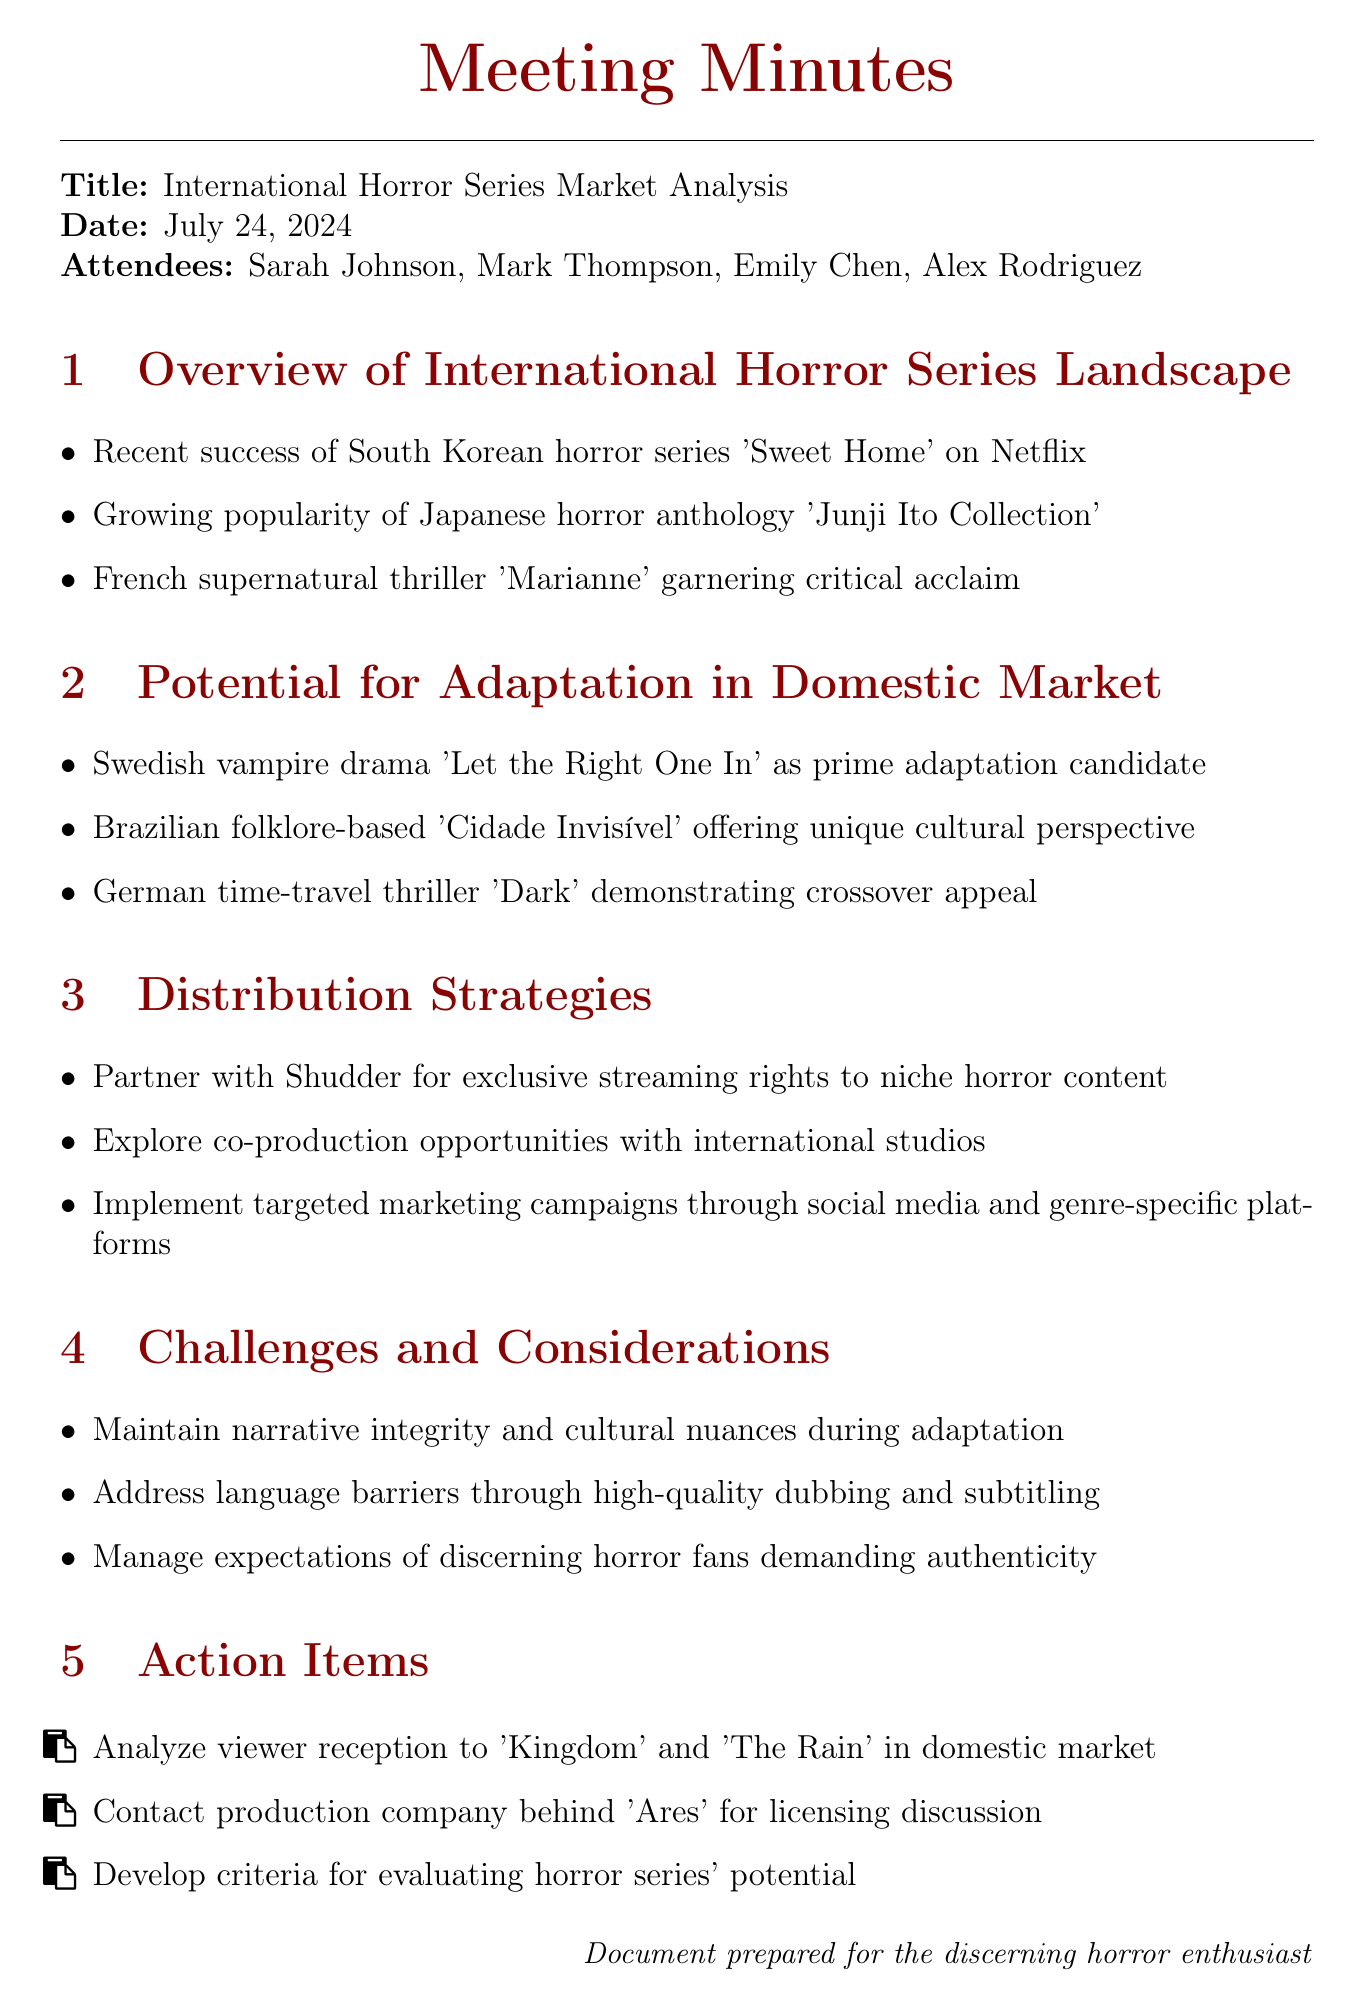What is the title of the meeting? The title of the meeting is provided at the beginning of the document.
Answer: International Horror Series Market Analysis Who is the market research analyst in the meeting? The attendees' list includes their respective roles, identifying the market research analyst.
Answer: Emily Chen Which South Korean horror series was mentioned as a recent success? The overview section lists key points, one of which includes the title of the successful series.
Answer: Sweet Home What international series is noted for its crossover appeal despite a complex narrative? The potential for adaptation section includes a specific German series that fits this description.
Answer: Dark What are the action items focused on? The action items section lists specific tasks to be undertaken, which can be summarized based on their context.
Answer: Analyzing viewer reception What is a challenge mentioned regarding adaptations? The challenges and considerations section highlights specific hurdles faced during adaptations, one of which involves narrative integrity.
Answer: Narrative integrity How many attendees were listed in the meeting? The document specifies the number of attendees in the introductory section.
Answer: Four Which streaming platform was mentioned for partnering? The distribution strategies section includes specific platforms explored for exclusive rights.
Answer: Shudder What is the unique perspective offered by 'Cidade Invisível'? The potential for adaptation section describes the cultural perspective of this Brazilian series.
Answer: Cultural perspective 